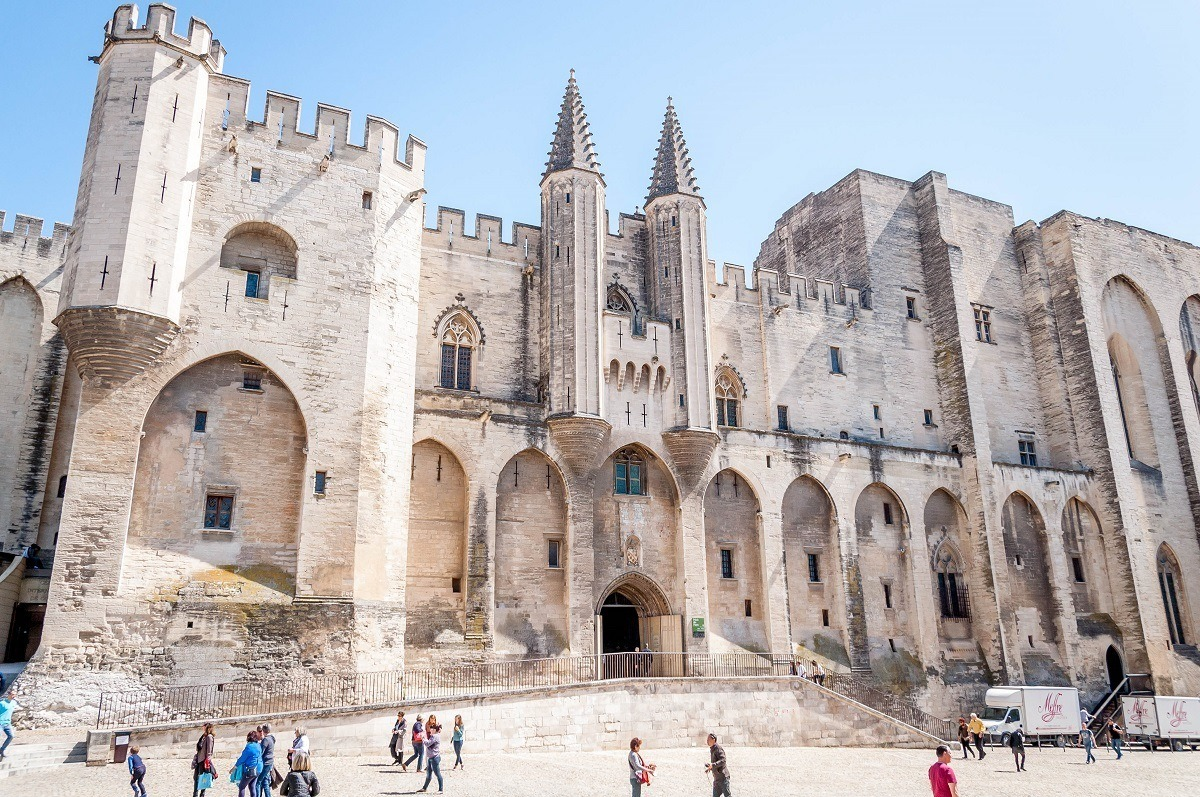What impact does this place have on modern-day Avignon? Today, the Papal Palace is a cornerstone of cultural and historical significance in Avignon. It attracts countless tourists, scholars, and history enthusiasts curious to delve into the rich past of the region. This influx of visitors bolsters the local economy, supporting businesses, and fostering a vibrant tourism industry. The palace also serves as a cultural hub, hosting events, exhibitions, and festivals, such as the renowned Festival d'Avignon, which transforms the city into a lively celebration of arts and culture. The presence of this ancient masterpiece conjoins the historical narrative with contemporary life, making it an integral part of Avignon's identity. 